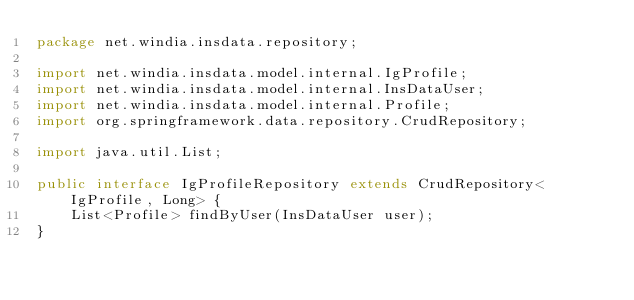Convert code to text. <code><loc_0><loc_0><loc_500><loc_500><_Java_>package net.windia.insdata.repository;

import net.windia.insdata.model.internal.IgProfile;
import net.windia.insdata.model.internal.InsDataUser;
import net.windia.insdata.model.internal.Profile;
import org.springframework.data.repository.CrudRepository;

import java.util.List;

public interface IgProfileRepository extends CrudRepository<IgProfile, Long> {
    List<Profile> findByUser(InsDataUser user);
}
</code> 